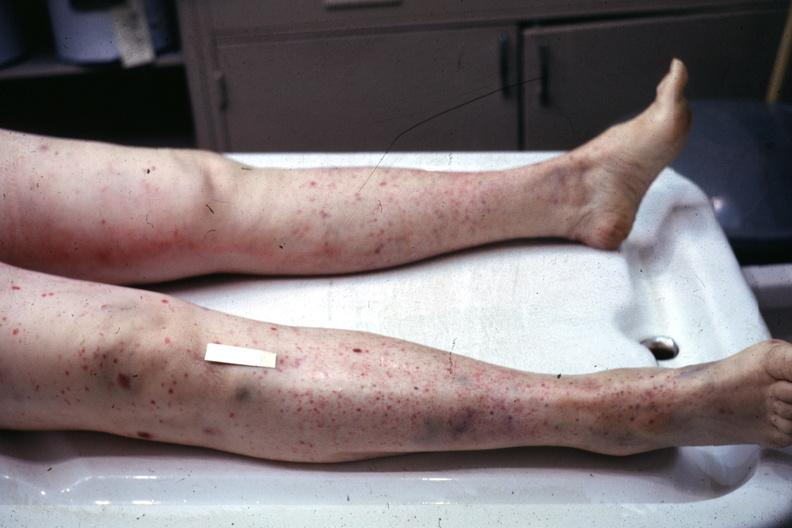what does this image show?
Answer the question using a single word or phrase. Ok but not close enough petechiae 